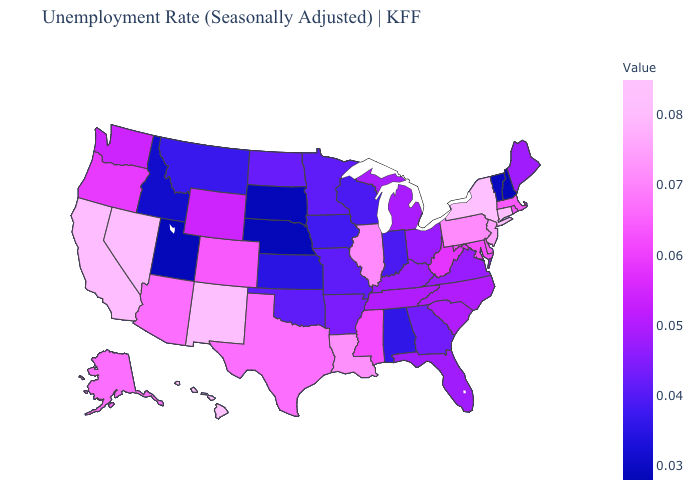Does Mississippi have a higher value than Idaho?
Be succinct. Yes. Which states have the highest value in the USA?
Quick response, please. Hawaii. Among the states that border North Carolina , which have the highest value?
Short answer required. South Carolina, Tennessee. Does Connecticut have the lowest value in the Northeast?
Keep it brief. No. Among the states that border Colorado , does Arizona have the highest value?
Answer briefly. No. 